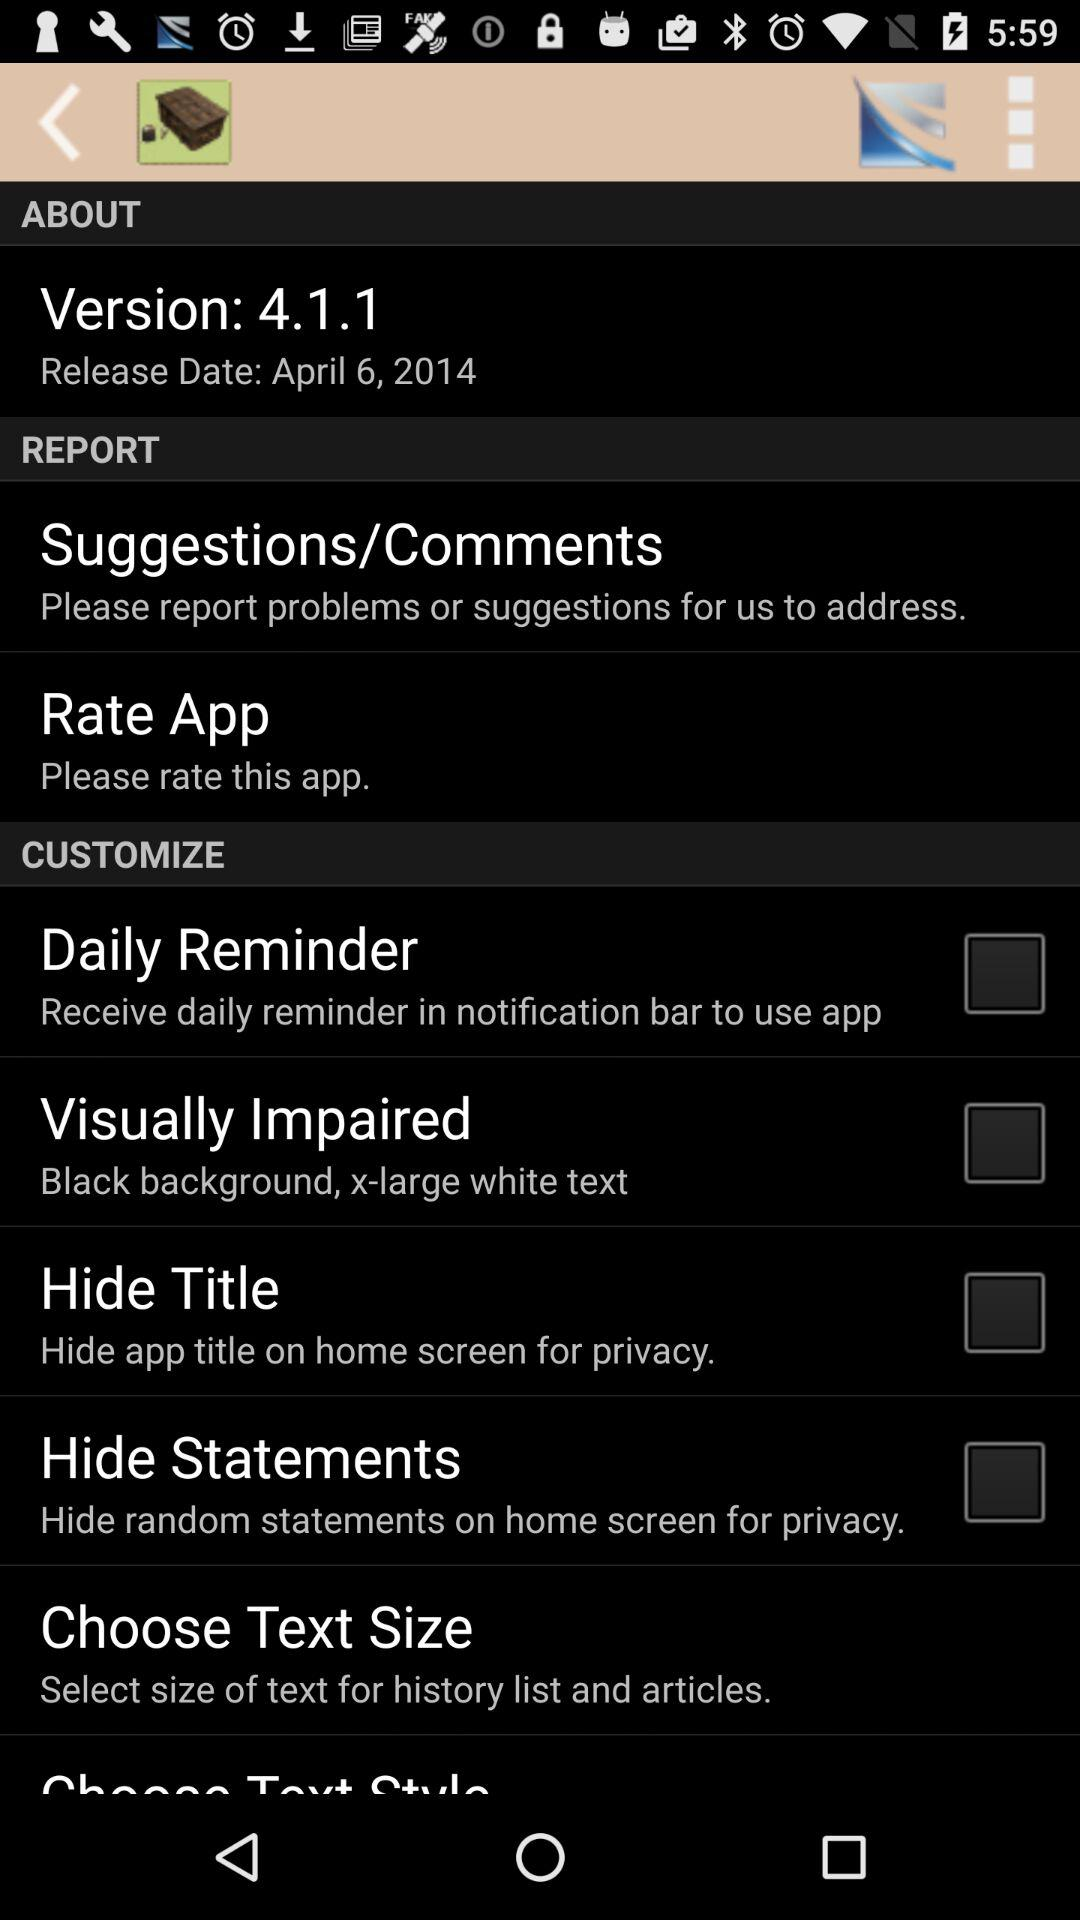What is the release date of version 4.1.1? The release date is April 6, 2014. 